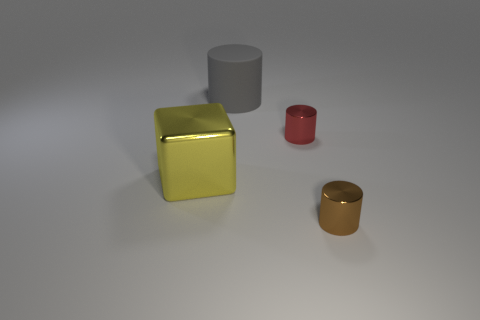Add 2 gray matte cylinders. How many objects exist? 6 Subtract all cubes. How many objects are left? 3 Subtract 0 gray balls. How many objects are left? 4 Subtract all gray rubber things. Subtract all big yellow metallic things. How many objects are left? 2 Add 1 red cylinders. How many red cylinders are left? 2 Add 2 large green metal things. How many large green metal things exist? 2 